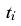<formula> <loc_0><loc_0><loc_500><loc_500>\tilde { t } _ { i }</formula> 